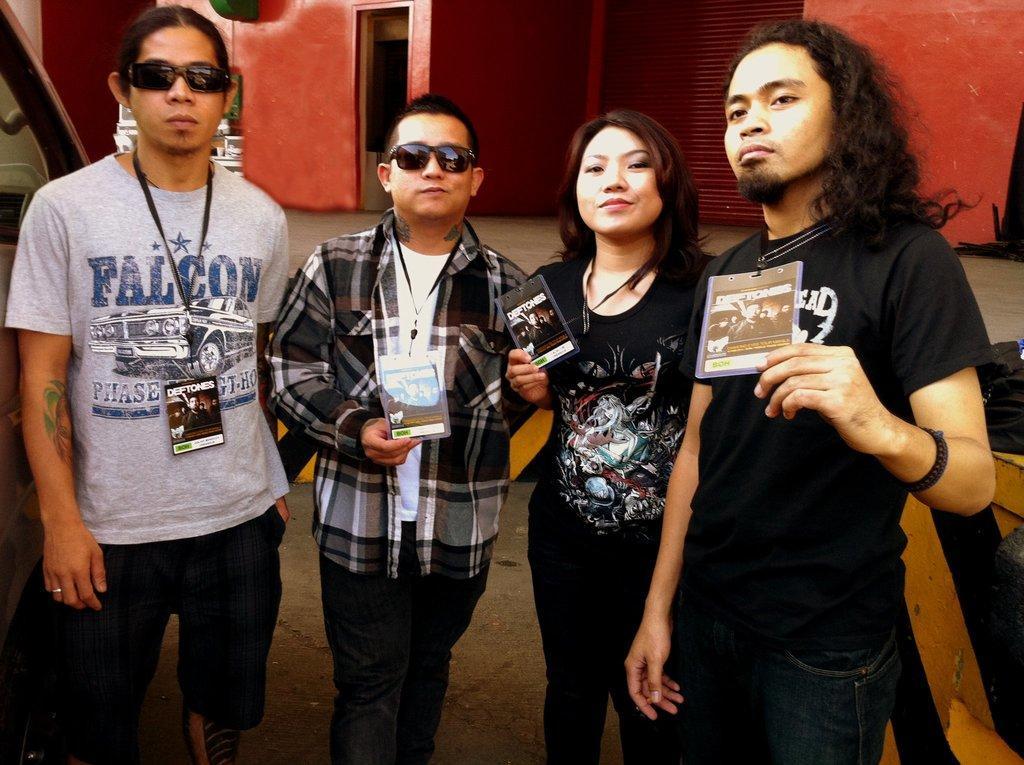Describe this image in one or two sentences. In the middle of the image four persons standing, smiling and holding tags. Behind them there is wall. Besides them there are two vehicles. 